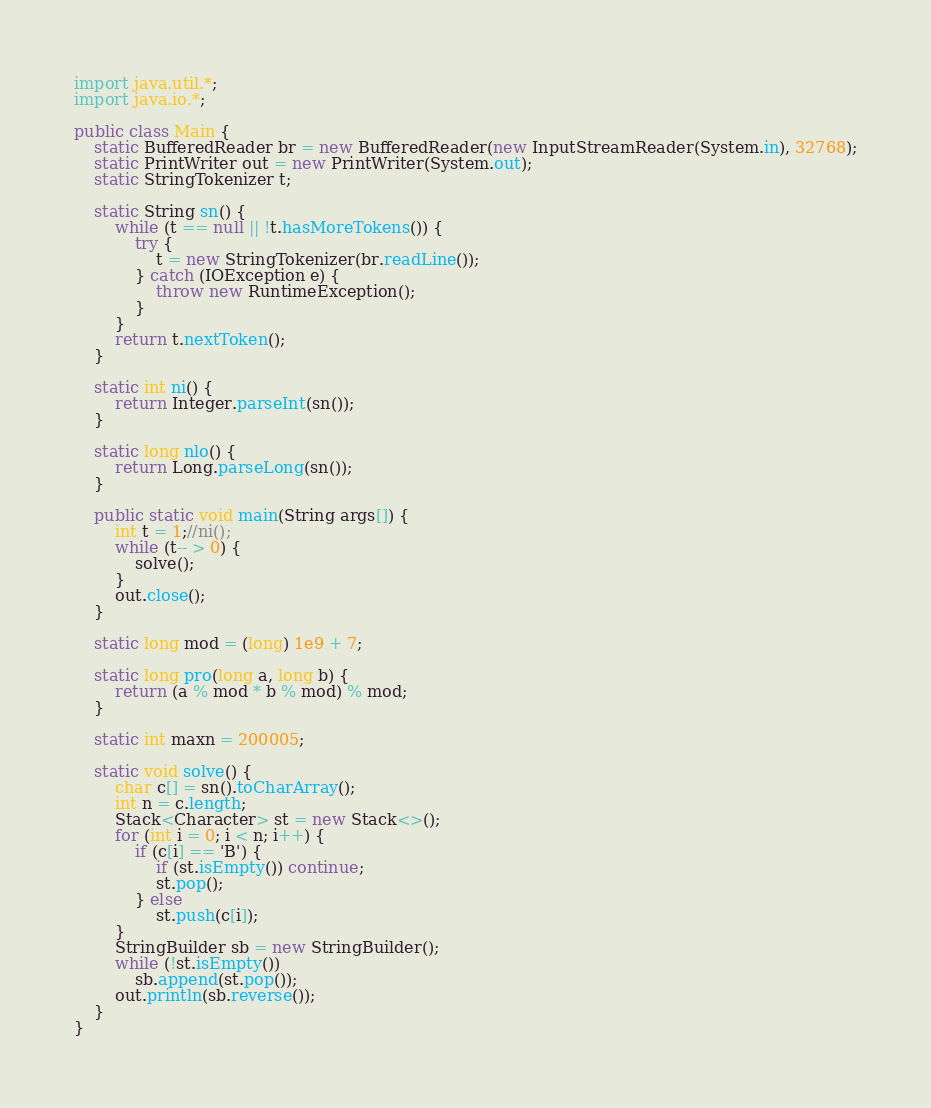Convert code to text. <code><loc_0><loc_0><loc_500><loc_500><_Java_>import java.util.*;
import java.io.*;

public class Main {
    static BufferedReader br = new BufferedReader(new InputStreamReader(System.in), 32768);
    static PrintWriter out = new PrintWriter(System.out);
    static StringTokenizer t;

    static String sn() {
        while (t == null || !t.hasMoreTokens()) {
            try {
                t = new StringTokenizer(br.readLine());
            } catch (IOException e) {
                throw new RuntimeException();
            }
        }
        return t.nextToken();
    }

    static int ni() {
        return Integer.parseInt(sn());
    }

    static long nlo() {
        return Long.parseLong(sn());
    }

    public static void main(String args[]) {
        int t = 1;//ni();
        while (t-- > 0) {
            solve();
        }
        out.close();
    }

    static long mod = (long) 1e9 + 7;

    static long pro(long a, long b) {
        return (a % mod * b % mod) % mod;
    }

    static int maxn = 200005;

    static void solve() {
        char c[] = sn().toCharArray();
        int n = c.length;
        Stack<Character> st = new Stack<>();
        for (int i = 0; i < n; i++) {
            if (c[i] == 'B') {
                if (st.isEmpty()) continue;
                st.pop();
            } else
                st.push(c[i]);
        }
        StringBuilder sb = new StringBuilder();
        while (!st.isEmpty())
            sb.append(st.pop());
        out.println(sb.reverse());
    }
}</code> 